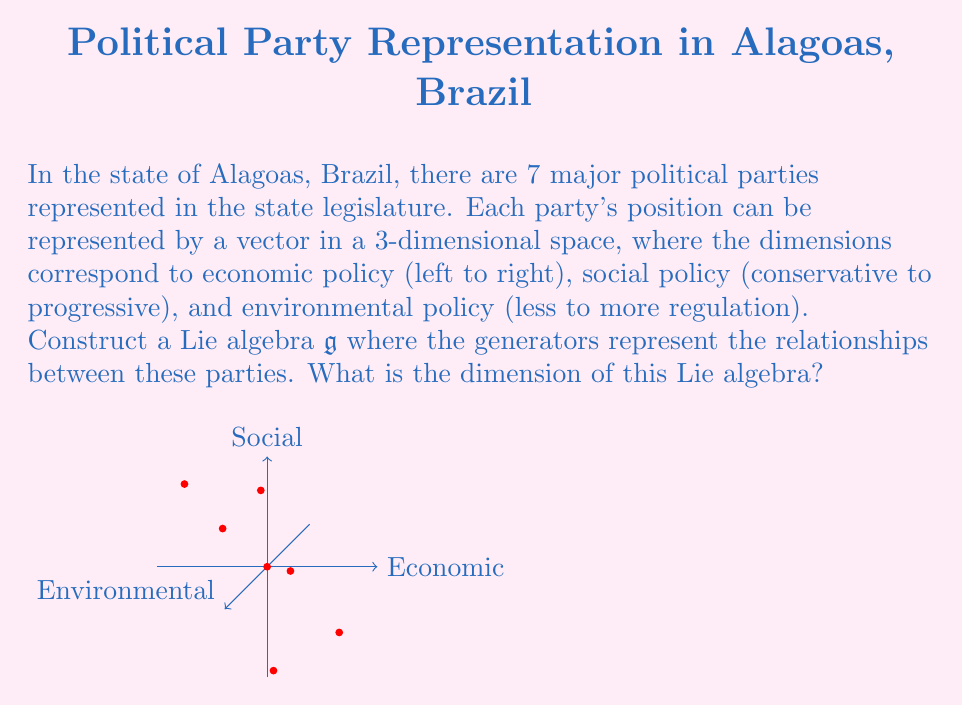Can you solve this math problem? To determine the dimension of the Lie algebra, we need to follow these steps:

1) First, recall that a Lie algebra is a vector space equipped with a Lie bracket operation. The dimension of a Lie algebra is the dimension of its underlying vector space.

2) In this case, we have 7 political parties, each represented by a 3-dimensional vector. These vectors form a basis for our Lie algebra $\mathfrak{g}$.

3) The generators of the Lie algebra will be the commutators (Lie brackets) between these basis vectors. For $n$ basis vectors, we can have $\binom{n}{2} = \frac{n(n-1)}{2}$ possible commutators.

4) With 7 basis vectors, we have:

   $$\binom{7}{2} = \frac{7(7-1)}{2} = \frac{7 \cdot 6}{2} = 21$$

   possible commutators.

5) However, not all of these commutators are necessarily linearly independent. The maximum dimension of the Lie algebra would be the number of basis vectors plus the number of independent commutators.

6) In the worst case (maximum dimension), all commutators are independent, so the dimension would be:

   $$7 + 21 = 28$$

7) Therefore, the dimension of the Lie algebra $\mathfrak{g}$ is at most 28.

It's important to note that the actual dimension could be less if there are linear dependencies among the commutators, but without more specific information about the relationships between the parties, we cannot determine a more precise dimension.
Answer: $\dim(\mathfrak{g}) \leq 28$ 